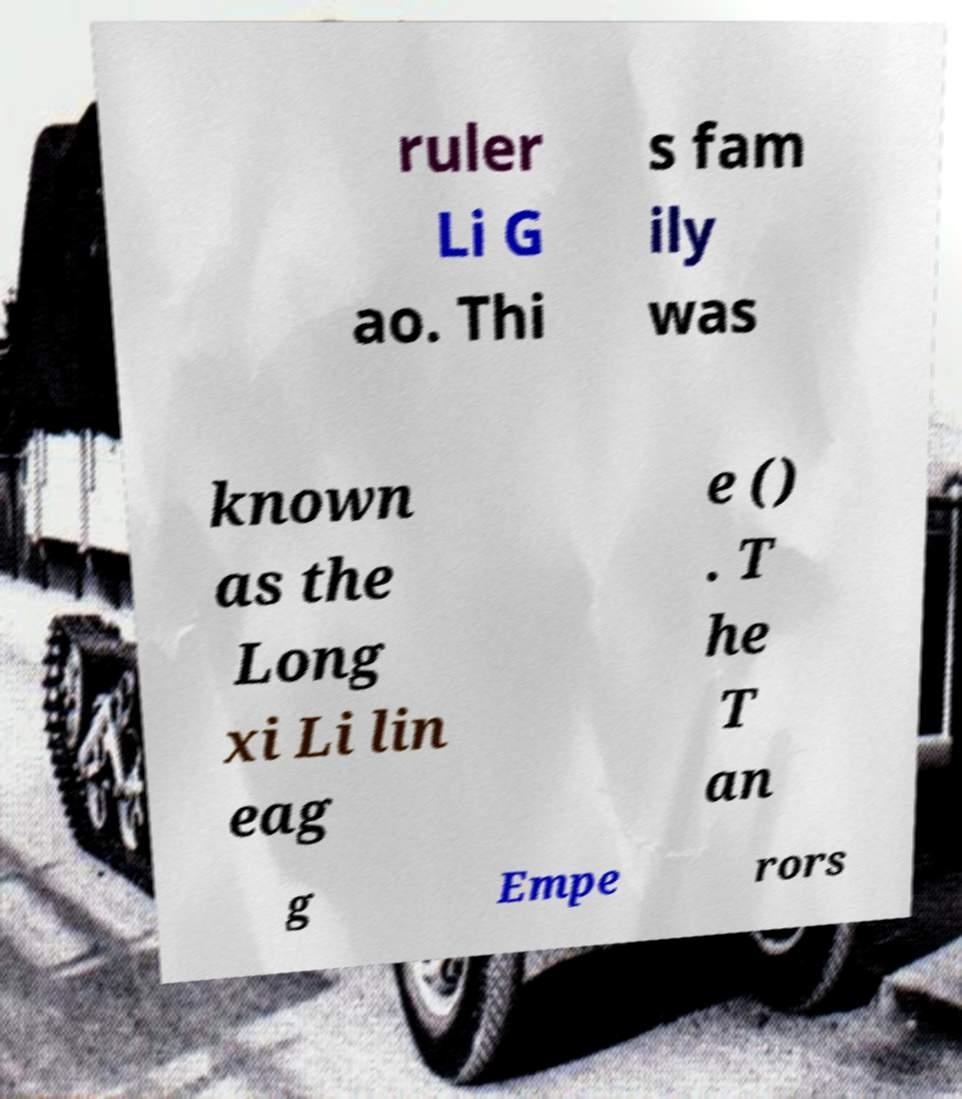There's text embedded in this image that I need extracted. Can you transcribe it verbatim? ruler Li G ao. Thi s fam ily was known as the Long xi Li lin eag e () . T he T an g Empe rors 